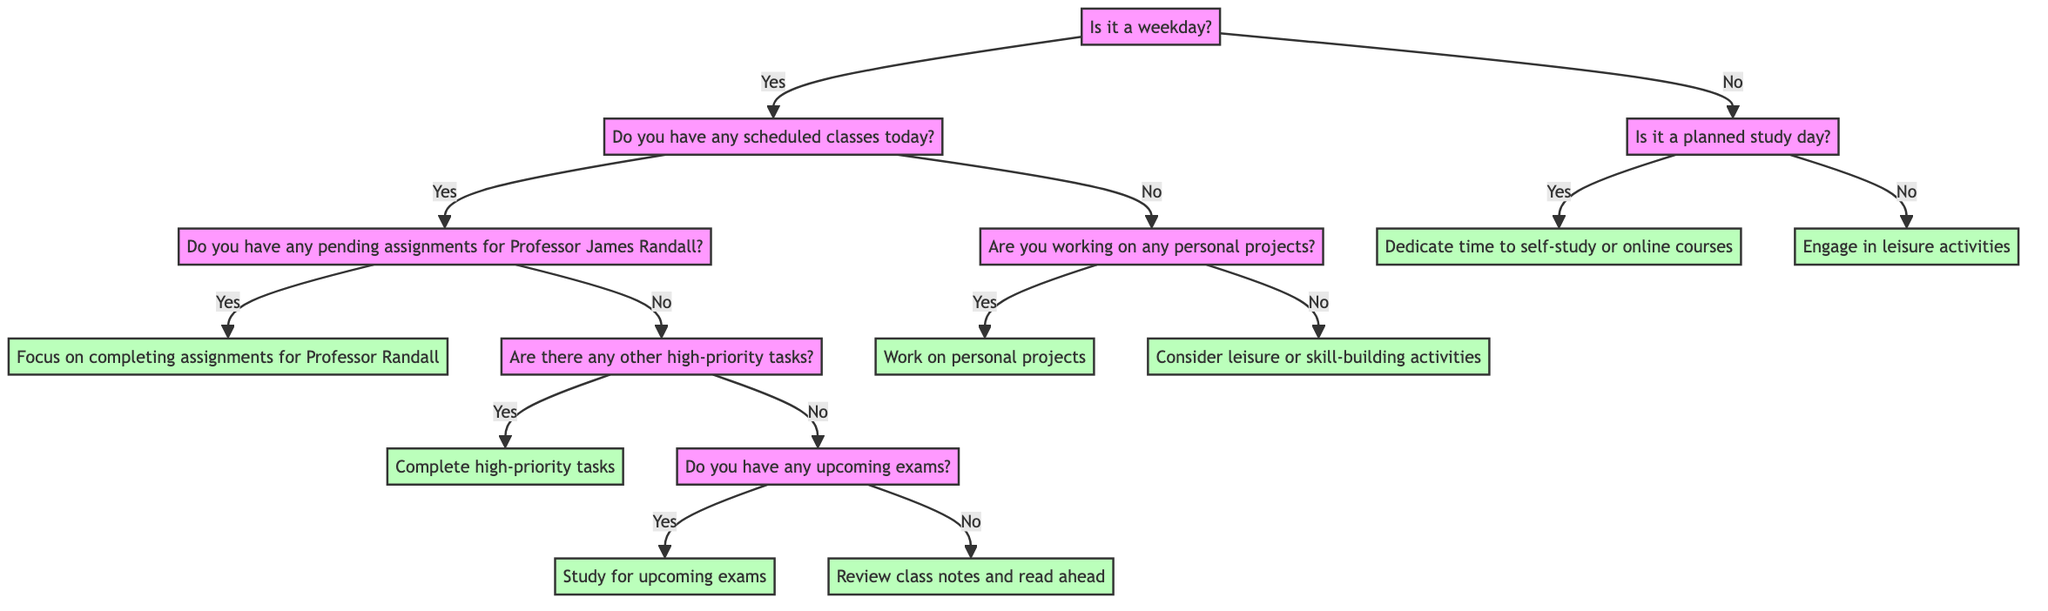Is it a weekday? The root question of the decision tree is "Is it a weekday?" which determines the path taken in the diagram. This node has two possible child nodes, leading to different branching based on the answer.
Answer: Yes What happens if today is a scheduled class day but there are no pending assignments for Professor James Randall? If today is a scheduled class day and there are no pending assignments for Professor James Randall, we follow the flow to the next question "Are there any other high-priority tasks?", leading to a decision to "Complete high-priority tasks".
Answer: Complete high-priority tasks How many activities are listed for leisure or skill-building activities if there are no personal projects? In the decision path where no personal projects are worked on, the diagram states to "Consider leisure or skill-building activities" and lists three specific activities: Exercise, Hobbies, and Learning a new skill. This indicates that there are three activities listed.
Answer: Three What activity is suggested if it is not a weekday and not a planned study day? If it is not a weekday and not a planned study day, the decision tree leads to the activity "Engage in leisure activities".
Answer: Engage in leisure activities If there are upcoming exams, what activity should be prioritized? When upcoming exams are present, the decision tree dictates the activity "Study for upcoming exams". This follows the logical flow from prior questions regarding scheduled classes and pending assignments.
Answer: Study for upcoming exams What is the first question to ask in the decision-making process? The initial inquiry in the decision tree is "Is it a weekday?", which is the first decision point determining subsequent nodes.
Answer: Is it a weekday? 